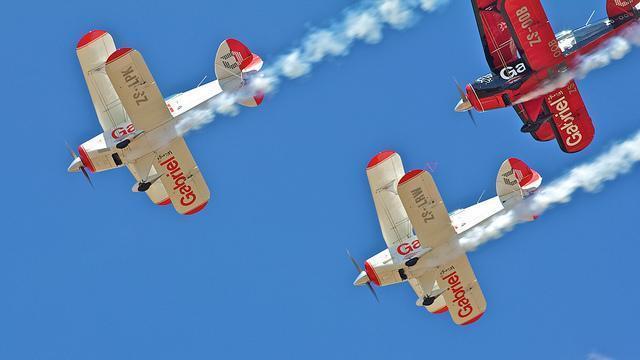How many planes can be seen?
Give a very brief answer. 3. How many airplanes can be seen?
Give a very brief answer. 3. How many toilets are pictured?
Give a very brief answer. 0. 